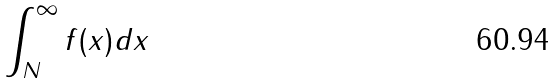Convert formula to latex. <formula><loc_0><loc_0><loc_500><loc_500>\int _ { N } ^ { \infty } f ( x ) d x</formula> 